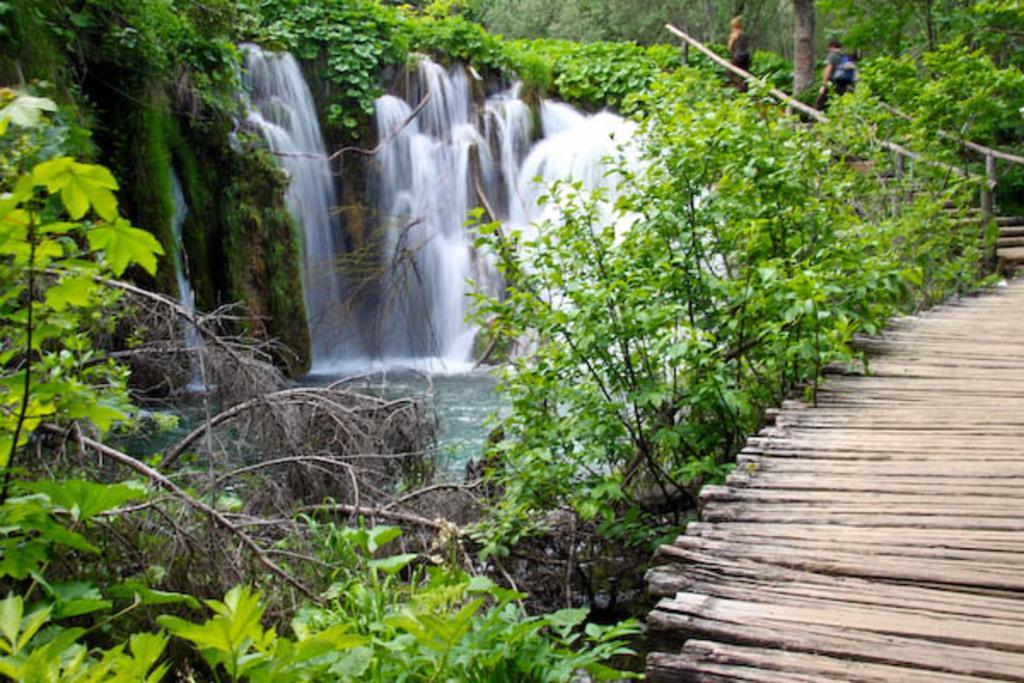Can you describe this image briefly? This [picture describe about the beautiful view of the nature. In front bottom side there is a wooden bridge and some plants. Behind we can see waterfall and some trees. 